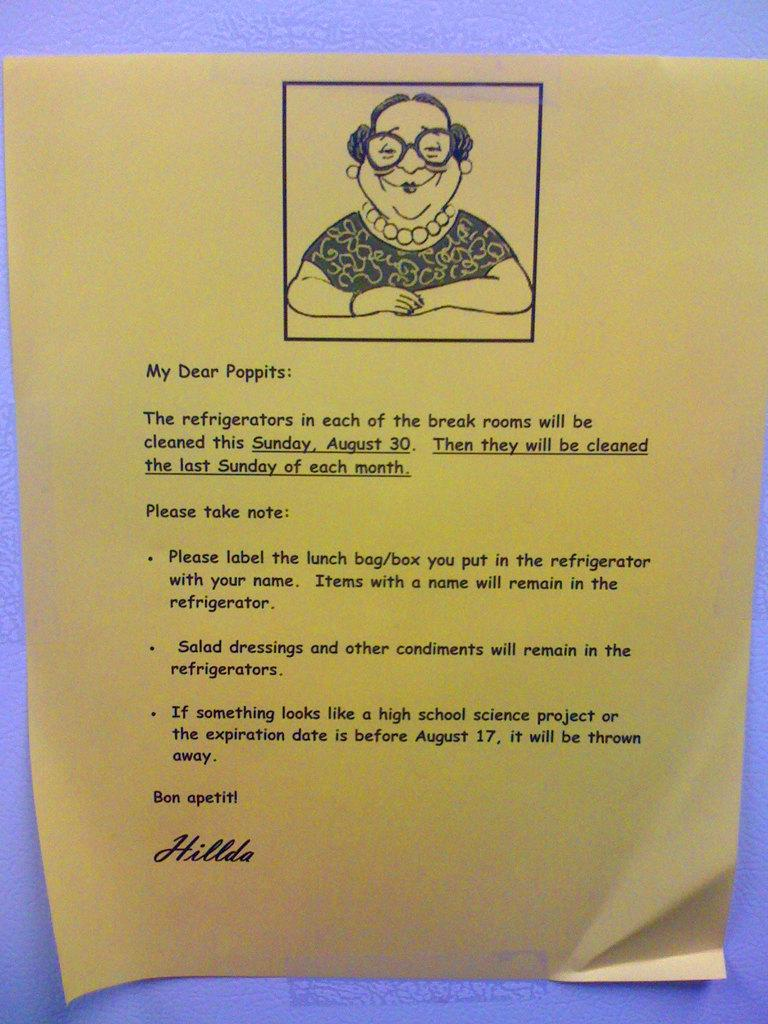What is the main object in the image? There is a form plate in the image. What is depicted on the form plate? The form plate contains a person. Are there any words or letters on the form plate? Yes, there is text on the form plate. What type of brain is visible on the form plate? There is no brain visible on the form plate; it contains a person and text. 